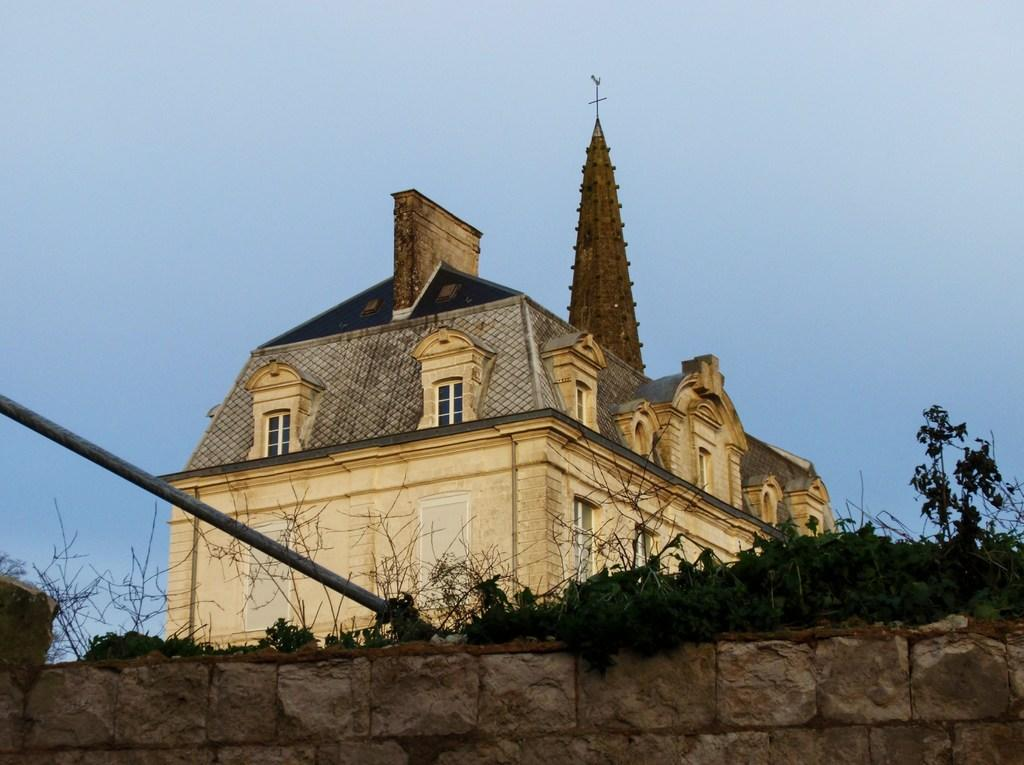What type of structure can be seen in the image? There is a wall in the image. What other elements are present in the image? There are plants, a pole, and a building with windows in the image. What can be seen in the background of the image? The sky is visible in the background of the image. What type of silver material is draped over the plants in the image? There is no silver material present in the image; it features plants, a wall, a pole, and a building with windows. How does the wool increase the aesthetic appeal of the building in the image? There is no wool mentioned in the image, and it does not affect the aesthetic appeal of the building. 